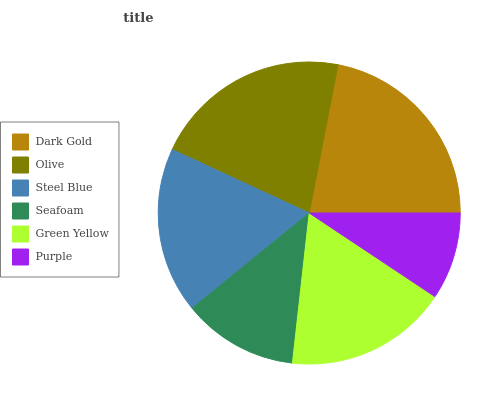Is Purple the minimum?
Answer yes or no. Yes. Is Dark Gold the maximum?
Answer yes or no. Yes. Is Olive the minimum?
Answer yes or no. No. Is Olive the maximum?
Answer yes or no. No. Is Dark Gold greater than Olive?
Answer yes or no. Yes. Is Olive less than Dark Gold?
Answer yes or no. Yes. Is Olive greater than Dark Gold?
Answer yes or no. No. Is Dark Gold less than Olive?
Answer yes or no. No. Is Steel Blue the high median?
Answer yes or no. Yes. Is Green Yellow the low median?
Answer yes or no. Yes. Is Dark Gold the high median?
Answer yes or no. No. Is Seafoam the low median?
Answer yes or no. No. 